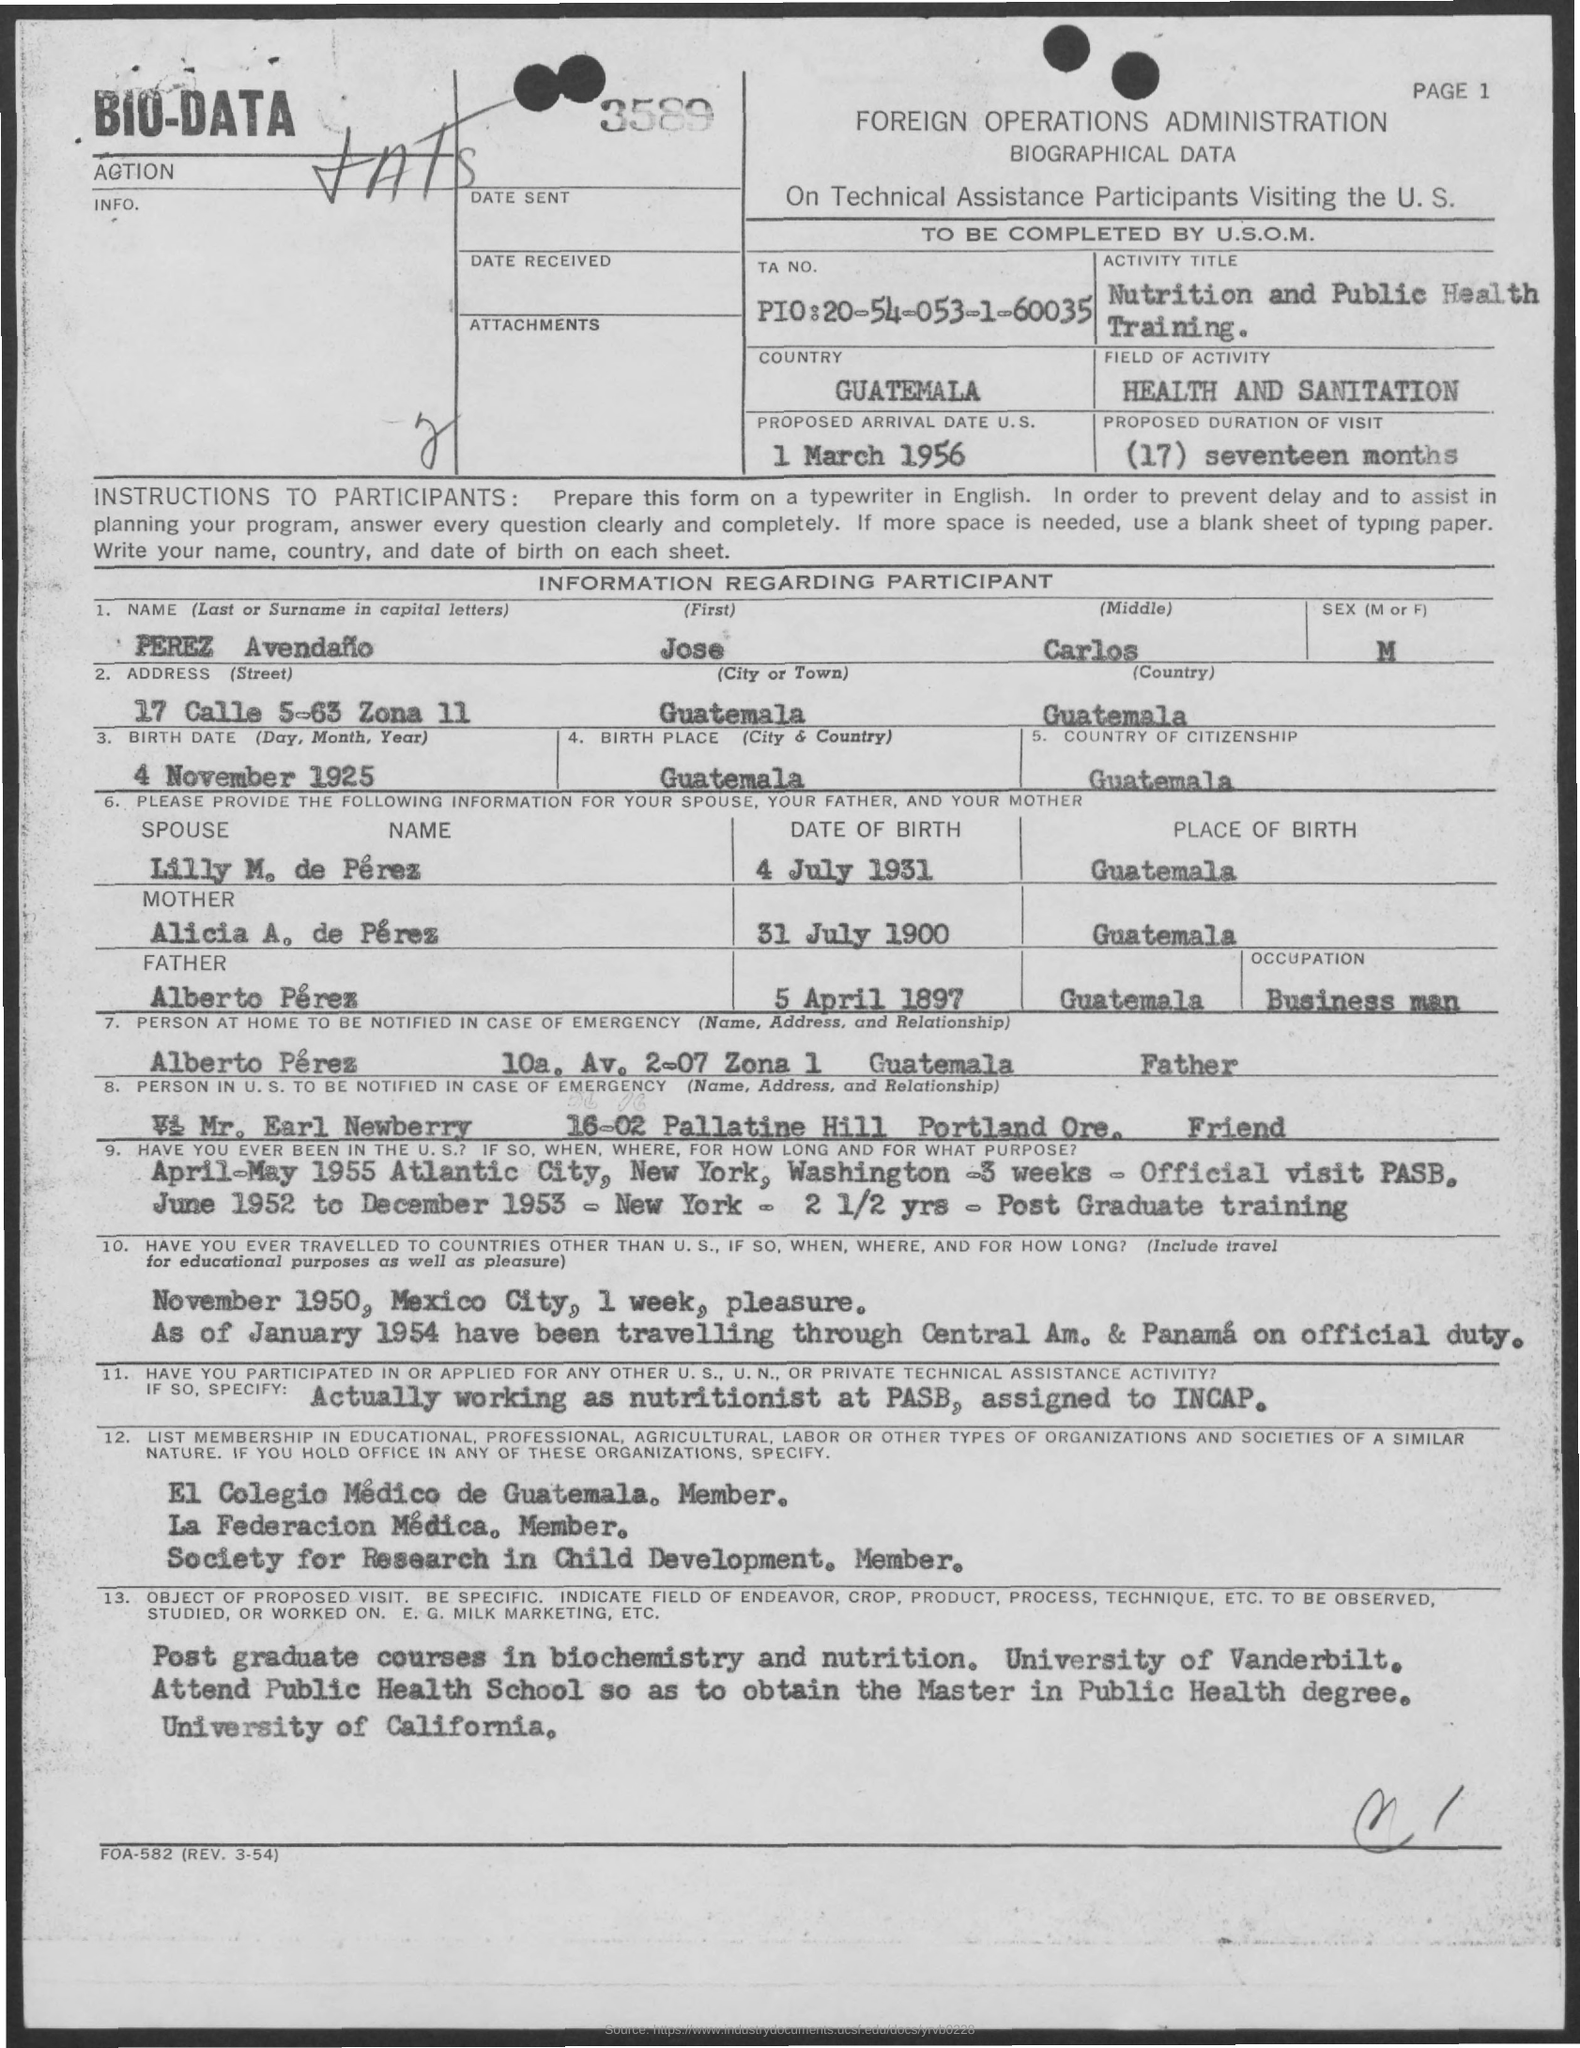How long is the proposed duration of Visit?
Make the answer very short. (17) Seventeen months. What is the first name of the participant?
Ensure brevity in your answer.  Jose. 